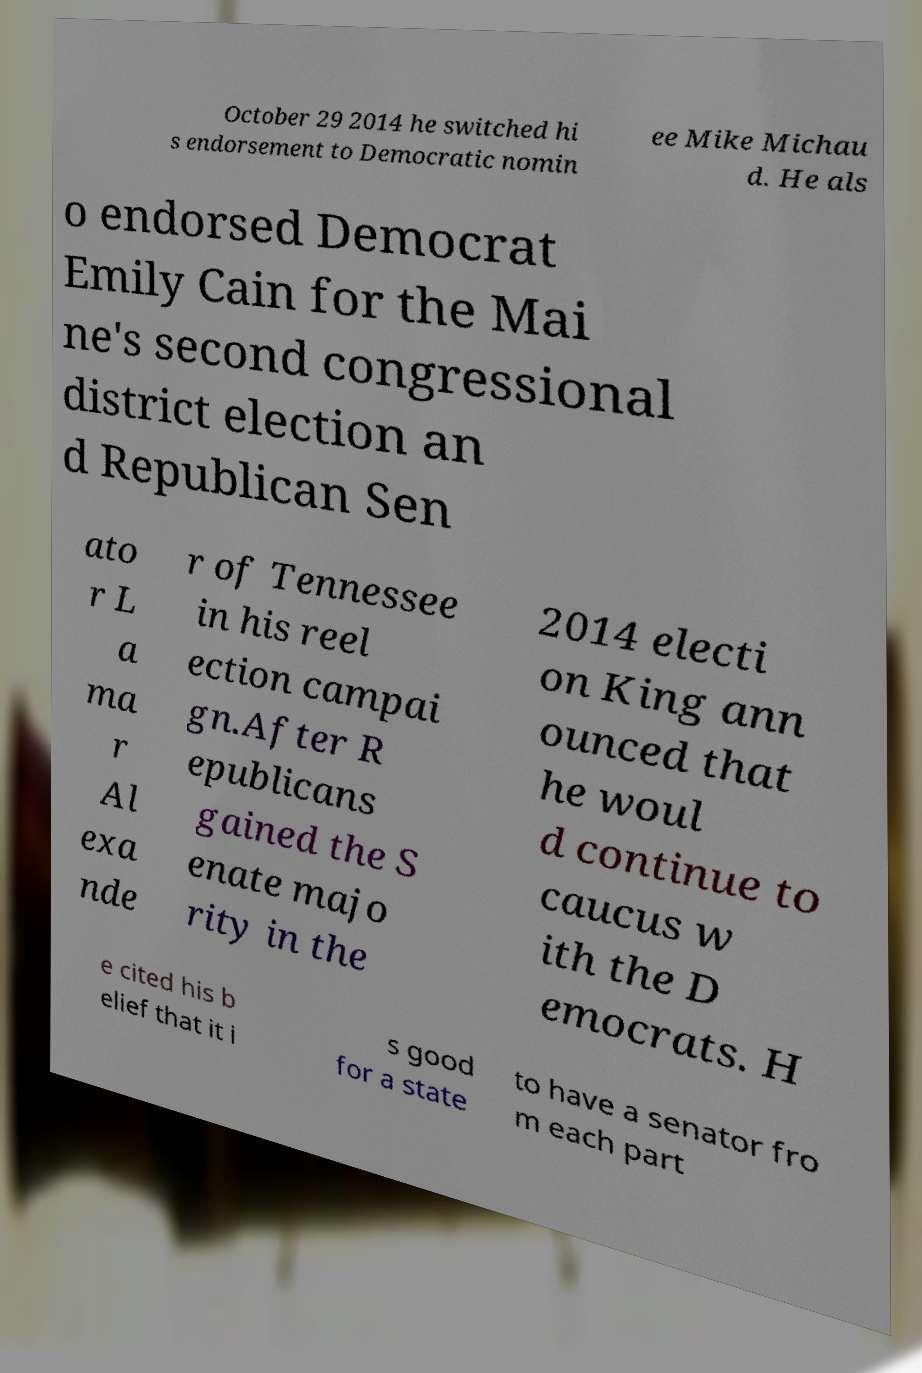Could you extract and type out the text from this image? October 29 2014 he switched hi s endorsement to Democratic nomin ee Mike Michau d. He als o endorsed Democrat Emily Cain for the Mai ne's second congressional district election an d Republican Sen ato r L a ma r Al exa nde r of Tennessee in his reel ection campai gn.After R epublicans gained the S enate majo rity in the 2014 electi on King ann ounced that he woul d continue to caucus w ith the D emocrats. H e cited his b elief that it i s good for a state to have a senator fro m each part 